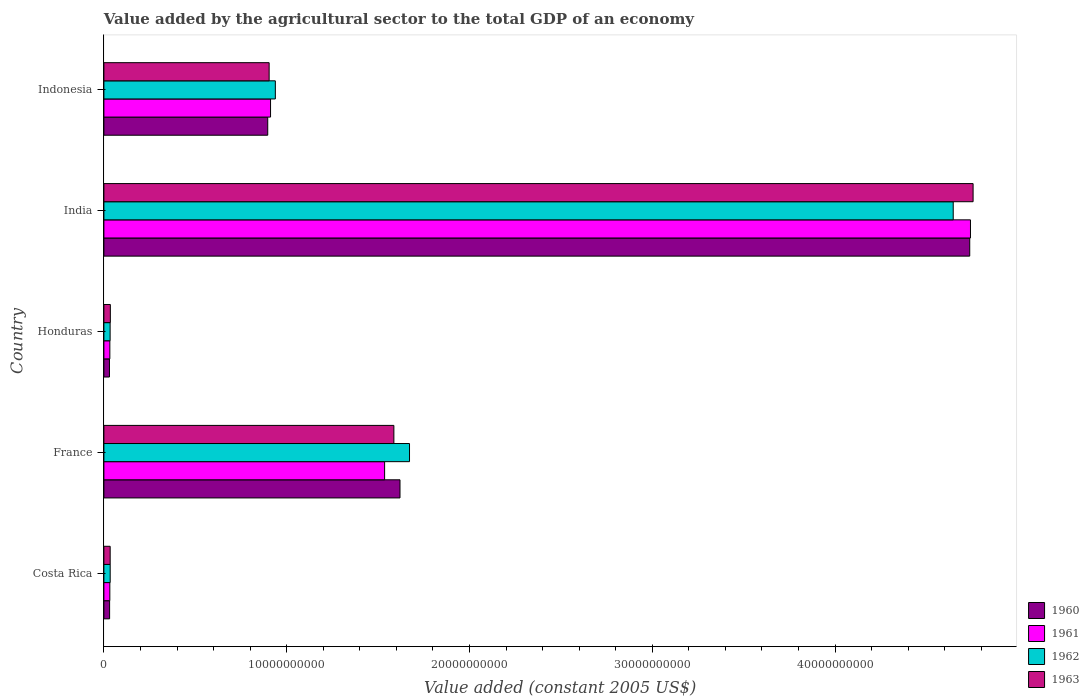Are the number of bars on each tick of the Y-axis equal?
Provide a succinct answer. Yes. How many bars are there on the 3rd tick from the top?
Your answer should be compact. 4. What is the value added by the agricultural sector in 1962 in Costa Rica?
Offer a very short reply. 3.44e+08. Across all countries, what is the maximum value added by the agricultural sector in 1962?
Your response must be concise. 4.65e+1. Across all countries, what is the minimum value added by the agricultural sector in 1960?
Your answer should be very brief. 3.05e+08. In which country was the value added by the agricultural sector in 1962 maximum?
Keep it short and to the point. India. In which country was the value added by the agricultural sector in 1960 minimum?
Make the answer very short. Honduras. What is the total value added by the agricultural sector in 1963 in the graph?
Your response must be concise. 7.32e+1. What is the difference between the value added by the agricultural sector in 1962 in Costa Rica and that in Honduras?
Your response must be concise. 3.61e+06. What is the difference between the value added by the agricultural sector in 1961 in India and the value added by the agricultural sector in 1963 in Honduras?
Keep it short and to the point. 4.71e+1. What is the average value added by the agricultural sector in 1961 per country?
Your answer should be very brief. 1.45e+1. What is the difference between the value added by the agricultural sector in 1962 and value added by the agricultural sector in 1963 in France?
Your answer should be compact. 8.56e+08. In how many countries, is the value added by the agricultural sector in 1961 greater than 40000000000 US$?
Offer a terse response. 1. What is the ratio of the value added by the agricultural sector in 1961 in Costa Rica to that in France?
Provide a short and direct response. 0.02. Is the value added by the agricultural sector in 1963 in France less than that in India?
Provide a succinct answer. Yes. What is the difference between the highest and the second highest value added by the agricultural sector in 1962?
Provide a succinct answer. 2.97e+1. What is the difference between the highest and the lowest value added by the agricultural sector in 1963?
Your answer should be compact. 4.72e+1. In how many countries, is the value added by the agricultural sector in 1960 greater than the average value added by the agricultural sector in 1960 taken over all countries?
Keep it short and to the point. 2. Is the sum of the value added by the agricultural sector in 1963 in India and Indonesia greater than the maximum value added by the agricultural sector in 1961 across all countries?
Provide a succinct answer. Yes. Where does the legend appear in the graph?
Keep it short and to the point. Bottom right. How many legend labels are there?
Make the answer very short. 4. How are the legend labels stacked?
Your answer should be very brief. Vertical. What is the title of the graph?
Offer a very short reply. Value added by the agricultural sector to the total GDP of an economy. Does "1996" appear as one of the legend labels in the graph?
Your answer should be very brief. No. What is the label or title of the X-axis?
Provide a short and direct response. Value added (constant 2005 US$). What is the Value added (constant 2005 US$) in 1960 in Costa Rica?
Offer a very short reply. 3.13e+08. What is the Value added (constant 2005 US$) in 1961 in Costa Rica?
Offer a very short reply. 3.24e+08. What is the Value added (constant 2005 US$) in 1962 in Costa Rica?
Keep it short and to the point. 3.44e+08. What is the Value added (constant 2005 US$) in 1963 in Costa Rica?
Provide a short and direct response. 3.43e+08. What is the Value added (constant 2005 US$) of 1960 in France?
Make the answer very short. 1.62e+1. What is the Value added (constant 2005 US$) of 1961 in France?
Offer a terse response. 1.54e+1. What is the Value added (constant 2005 US$) of 1962 in France?
Your answer should be very brief. 1.67e+1. What is the Value added (constant 2005 US$) in 1963 in France?
Offer a very short reply. 1.59e+1. What is the Value added (constant 2005 US$) of 1960 in Honduras?
Offer a terse response. 3.05e+08. What is the Value added (constant 2005 US$) of 1961 in Honduras?
Ensure brevity in your answer.  3.25e+08. What is the Value added (constant 2005 US$) in 1962 in Honduras?
Ensure brevity in your answer.  3.41e+08. What is the Value added (constant 2005 US$) of 1963 in Honduras?
Ensure brevity in your answer.  3.53e+08. What is the Value added (constant 2005 US$) in 1960 in India?
Provide a succinct answer. 4.74e+1. What is the Value added (constant 2005 US$) of 1961 in India?
Make the answer very short. 4.74e+1. What is the Value added (constant 2005 US$) in 1962 in India?
Offer a terse response. 4.65e+1. What is the Value added (constant 2005 US$) of 1963 in India?
Ensure brevity in your answer.  4.76e+1. What is the Value added (constant 2005 US$) in 1960 in Indonesia?
Provide a short and direct response. 8.96e+09. What is the Value added (constant 2005 US$) of 1961 in Indonesia?
Provide a succinct answer. 9.12e+09. What is the Value added (constant 2005 US$) in 1962 in Indonesia?
Your answer should be compact. 9.38e+09. What is the Value added (constant 2005 US$) in 1963 in Indonesia?
Ensure brevity in your answer.  9.04e+09. Across all countries, what is the maximum Value added (constant 2005 US$) in 1960?
Make the answer very short. 4.74e+1. Across all countries, what is the maximum Value added (constant 2005 US$) of 1961?
Offer a terse response. 4.74e+1. Across all countries, what is the maximum Value added (constant 2005 US$) of 1962?
Ensure brevity in your answer.  4.65e+1. Across all countries, what is the maximum Value added (constant 2005 US$) of 1963?
Your answer should be very brief. 4.76e+1. Across all countries, what is the minimum Value added (constant 2005 US$) in 1960?
Ensure brevity in your answer.  3.05e+08. Across all countries, what is the minimum Value added (constant 2005 US$) in 1961?
Offer a terse response. 3.24e+08. Across all countries, what is the minimum Value added (constant 2005 US$) in 1962?
Your response must be concise. 3.41e+08. Across all countries, what is the minimum Value added (constant 2005 US$) of 1963?
Ensure brevity in your answer.  3.43e+08. What is the total Value added (constant 2005 US$) of 1960 in the graph?
Ensure brevity in your answer.  7.31e+1. What is the total Value added (constant 2005 US$) in 1961 in the graph?
Your response must be concise. 7.25e+1. What is the total Value added (constant 2005 US$) of 1962 in the graph?
Keep it short and to the point. 7.32e+1. What is the total Value added (constant 2005 US$) in 1963 in the graph?
Offer a very short reply. 7.32e+1. What is the difference between the Value added (constant 2005 US$) in 1960 in Costa Rica and that in France?
Give a very brief answer. -1.59e+1. What is the difference between the Value added (constant 2005 US$) of 1961 in Costa Rica and that in France?
Offer a terse response. -1.50e+1. What is the difference between the Value added (constant 2005 US$) in 1962 in Costa Rica and that in France?
Provide a succinct answer. -1.64e+1. What is the difference between the Value added (constant 2005 US$) of 1963 in Costa Rica and that in France?
Give a very brief answer. -1.55e+1. What is the difference between the Value added (constant 2005 US$) in 1960 in Costa Rica and that in Honduras?
Keep it short and to the point. 7.61e+06. What is the difference between the Value added (constant 2005 US$) in 1961 in Costa Rica and that in Honduras?
Make the answer very short. -8.14e+05. What is the difference between the Value added (constant 2005 US$) of 1962 in Costa Rica and that in Honduras?
Provide a short and direct response. 3.61e+06. What is the difference between the Value added (constant 2005 US$) of 1963 in Costa Rica and that in Honduras?
Your answer should be very brief. -9.78e+06. What is the difference between the Value added (constant 2005 US$) of 1960 in Costa Rica and that in India?
Offer a terse response. -4.71e+1. What is the difference between the Value added (constant 2005 US$) of 1961 in Costa Rica and that in India?
Your response must be concise. -4.71e+1. What is the difference between the Value added (constant 2005 US$) of 1962 in Costa Rica and that in India?
Your answer should be compact. -4.61e+1. What is the difference between the Value added (constant 2005 US$) of 1963 in Costa Rica and that in India?
Provide a short and direct response. -4.72e+1. What is the difference between the Value added (constant 2005 US$) of 1960 in Costa Rica and that in Indonesia?
Make the answer very short. -8.65e+09. What is the difference between the Value added (constant 2005 US$) of 1961 in Costa Rica and that in Indonesia?
Keep it short and to the point. -8.79e+09. What is the difference between the Value added (constant 2005 US$) of 1962 in Costa Rica and that in Indonesia?
Offer a very short reply. -9.03e+09. What is the difference between the Value added (constant 2005 US$) of 1963 in Costa Rica and that in Indonesia?
Make the answer very short. -8.70e+09. What is the difference between the Value added (constant 2005 US$) in 1960 in France and that in Honduras?
Make the answer very short. 1.59e+1. What is the difference between the Value added (constant 2005 US$) of 1961 in France and that in Honduras?
Provide a short and direct response. 1.50e+1. What is the difference between the Value added (constant 2005 US$) of 1962 in France and that in Honduras?
Provide a succinct answer. 1.64e+1. What is the difference between the Value added (constant 2005 US$) in 1963 in France and that in Honduras?
Make the answer very short. 1.55e+1. What is the difference between the Value added (constant 2005 US$) of 1960 in France and that in India?
Your answer should be compact. -3.12e+1. What is the difference between the Value added (constant 2005 US$) in 1961 in France and that in India?
Make the answer very short. -3.21e+1. What is the difference between the Value added (constant 2005 US$) of 1962 in France and that in India?
Your response must be concise. -2.97e+1. What is the difference between the Value added (constant 2005 US$) of 1963 in France and that in India?
Your answer should be compact. -3.17e+1. What is the difference between the Value added (constant 2005 US$) in 1960 in France and that in Indonesia?
Your response must be concise. 7.24e+09. What is the difference between the Value added (constant 2005 US$) of 1961 in France and that in Indonesia?
Your answer should be very brief. 6.24e+09. What is the difference between the Value added (constant 2005 US$) of 1962 in France and that in Indonesia?
Provide a short and direct response. 7.34e+09. What is the difference between the Value added (constant 2005 US$) of 1963 in France and that in Indonesia?
Give a very brief answer. 6.82e+09. What is the difference between the Value added (constant 2005 US$) in 1960 in Honduras and that in India?
Give a very brief answer. -4.71e+1. What is the difference between the Value added (constant 2005 US$) of 1961 in Honduras and that in India?
Offer a terse response. -4.71e+1. What is the difference between the Value added (constant 2005 US$) in 1962 in Honduras and that in India?
Provide a succinct answer. -4.61e+1. What is the difference between the Value added (constant 2005 US$) in 1963 in Honduras and that in India?
Your answer should be compact. -4.72e+1. What is the difference between the Value added (constant 2005 US$) in 1960 in Honduras and that in Indonesia?
Your answer should be very brief. -8.66e+09. What is the difference between the Value added (constant 2005 US$) in 1961 in Honduras and that in Indonesia?
Your answer should be compact. -8.79e+09. What is the difference between the Value added (constant 2005 US$) of 1962 in Honduras and that in Indonesia?
Offer a very short reply. -9.04e+09. What is the difference between the Value added (constant 2005 US$) in 1963 in Honduras and that in Indonesia?
Your answer should be very brief. -8.69e+09. What is the difference between the Value added (constant 2005 US$) of 1960 in India and that in Indonesia?
Your answer should be compact. 3.84e+1. What is the difference between the Value added (constant 2005 US$) of 1961 in India and that in Indonesia?
Keep it short and to the point. 3.83e+1. What is the difference between the Value added (constant 2005 US$) of 1962 in India and that in Indonesia?
Make the answer very short. 3.71e+1. What is the difference between the Value added (constant 2005 US$) of 1963 in India and that in Indonesia?
Keep it short and to the point. 3.85e+1. What is the difference between the Value added (constant 2005 US$) in 1960 in Costa Rica and the Value added (constant 2005 US$) in 1961 in France?
Give a very brief answer. -1.50e+1. What is the difference between the Value added (constant 2005 US$) of 1960 in Costa Rica and the Value added (constant 2005 US$) of 1962 in France?
Give a very brief answer. -1.64e+1. What is the difference between the Value added (constant 2005 US$) in 1960 in Costa Rica and the Value added (constant 2005 US$) in 1963 in France?
Provide a succinct answer. -1.56e+1. What is the difference between the Value added (constant 2005 US$) in 1961 in Costa Rica and the Value added (constant 2005 US$) in 1962 in France?
Offer a terse response. -1.64e+1. What is the difference between the Value added (constant 2005 US$) of 1961 in Costa Rica and the Value added (constant 2005 US$) of 1963 in France?
Keep it short and to the point. -1.55e+1. What is the difference between the Value added (constant 2005 US$) in 1962 in Costa Rica and the Value added (constant 2005 US$) in 1963 in France?
Make the answer very short. -1.55e+1. What is the difference between the Value added (constant 2005 US$) of 1960 in Costa Rica and the Value added (constant 2005 US$) of 1961 in Honduras?
Give a very brief answer. -1.23e+07. What is the difference between the Value added (constant 2005 US$) of 1960 in Costa Rica and the Value added (constant 2005 US$) of 1962 in Honduras?
Your response must be concise. -2.78e+07. What is the difference between the Value added (constant 2005 US$) in 1960 in Costa Rica and the Value added (constant 2005 US$) in 1963 in Honduras?
Make the answer very short. -4.02e+07. What is the difference between the Value added (constant 2005 US$) in 1961 in Costa Rica and the Value added (constant 2005 US$) in 1962 in Honduras?
Give a very brief answer. -1.63e+07. What is the difference between the Value added (constant 2005 US$) in 1961 in Costa Rica and the Value added (constant 2005 US$) in 1963 in Honduras?
Keep it short and to the point. -2.87e+07. What is the difference between the Value added (constant 2005 US$) of 1962 in Costa Rica and the Value added (constant 2005 US$) of 1963 in Honduras?
Provide a succinct answer. -8.78e+06. What is the difference between the Value added (constant 2005 US$) of 1960 in Costa Rica and the Value added (constant 2005 US$) of 1961 in India?
Your answer should be very brief. -4.71e+1. What is the difference between the Value added (constant 2005 US$) of 1960 in Costa Rica and the Value added (constant 2005 US$) of 1962 in India?
Your answer should be very brief. -4.62e+1. What is the difference between the Value added (constant 2005 US$) in 1960 in Costa Rica and the Value added (constant 2005 US$) in 1963 in India?
Your answer should be very brief. -4.72e+1. What is the difference between the Value added (constant 2005 US$) in 1961 in Costa Rica and the Value added (constant 2005 US$) in 1962 in India?
Offer a very short reply. -4.61e+1. What is the difference between the Value added (constant 2005 US$) of 1961 in Costa Rica and the Value added (constant 2005 US$) of 1963 in India?
Your response must be concise. -4.72e+1. What is the difference between the Value added (constant 2005 US$) in 1962 in Costa Rica and the Value added (constant 2005 US$) in 1963 in India?
Provide a succinct answer. -4.72e+1. What is the difference between the Value added (constant 2005 US$) of 1960 in Costa Rica and the Value added (constant 2005 US$) of 1961 in Indonesia?
Ensure brevity in your answer.  -8.80e+09. What is the difference between the Value added (constant 2005 US$) of 1960 in Costa Rica and the Value added (constant 2005 US$) of 1962 in Indonesia?
Your answer should be compact. -9.07e+09. What is the difference between the Value added (constant 2005 US$) of 1960 in Costa Rica and the Value added (constant 2005 US$) of 1963 in Indonesia?
Give a very brief answer. -8.73e+09. What is the difference between the Value added (constant 2005 US$) of 1961 in Costa Rica and the Value added (constant 2005 US$) of 1962 in Indonesia?
Your answer should be compact. -9.05e+09. What is the difference between the Value added (constant 2005 US$) of 1961 in Costa Rica and the Value added (constant 2005 US$) of 1963 in Indonesia?
Offer a very short reply. -8.72e+09. What is the difference between the Value added (constant 2005 US$) of 1962 in Costa Rica and the Value added (constant 2005 US$) of 1963 in Indonesia?
Offer a terse response. -8.70e+09. What is the difference between the Value added (constant 2005 US$) of 1960 in France and the Value added (constant 2005 US$) of 1961 in Honduras?
Provide a short and direct response. 1.59e+1. What is the difference between the Value added (constant 2005 US$) of 1960 in France and the Value added (constant 2005 US$) of 1962 in Honduras?
Make the answer very short. 1.59e+1. What is the difference between the Value added (constant 2005 US$) in 1960 in France and the Value added (constant 2005 US$) in 1963 in Honduras?
Give a very brief answer. 1.58e+1. What is the difference between the Value added (constant 2005 US$) of 1961 in France and the Value added (constant 2005 US$) of 1962 in Honduras?
Ensure brevity in your answer.  1.50e+1. What is the difference between the Value added (constant 2005 US$) in 1961 in France and the Value added (constant 2005 US$) in 1963 in Honduras?
Offer a terse response. 1.50e+1. What is the difference between the Value added (constant 2005 US$) in 1962 in France and the Value added (constant 2005 US$) in 1963 in Honduras?
Your response must be concise. 1.64e+1. What is the difference between the Value added (constant 2005 US$) of 1960 in France and the Value added (constant 2005 US$) of 1961 in India?
Keep it short and to the point. -3.12e+1. What is the difference between the Value added (constant 2005 US$) in 1960 in France and the Value added (constant 2005 US$) in 1962 in India?
Make the answer very short. -3.03e+1. What is the difference between the Value added (constant 2005 US$) of 1960 in France and the Value added (constant 2005 US$) of 1963 in India?
Offer a very short reply. -3.14e+1. What is the difference between the Value added (constant 2005 US$) in 1961 in France and the Value added (constant 2005 US$) in 1962 in India?
Offer a terse response. -3.11e+1. What is the difference between the Value added (constant 2005 US$) in 1961 in France and the Value added (constant 2005 US$) in 1963 in India?
Offer a terse response. -3.22e+1. What is the difference between the Value added (constant 2005 US$) in 1962 in France and the Value added (constant 2005 US$) in 1963 in India?
Provide a succinct answer. -3.08e+1. What is the difference between the Value added (constant 2005 US$) in 1960 in France and the Value added (constant 2005 US$) in 1961 in Indonesia?
Provide a succinct answer. 7.08e+09. What is the difference between the Value added (constant 2005 US$) of 1960 in France and the Value added (constant 2005 US$) of 1962 in Indonesia?
Your response must be concise. 6.82e+09. What is the difference between the Value added (constant 2005 US$) of 1960 in France and the Value added (constant 2005 US$) of 1963 in Indonesia?
Provide a short and direct response. 7.16e+09. What is the difference between the Value added (constant 2005 US$) in 1961 in France and the Value added (constant 2005 US$) in 1962 in Indonesia?
Provide a short and direct response. 5.98e+09. What is the difference between the Value added (constant 2005 US$) in 1961 in France and the Value added (constant 2005 US$) in 1963 in Indonesia?
Provide a short and direct response. 6.32e+09. What is the difference between the Value added (constant 2005 US$) in 1962 in France and the Value added (constant 2005 US$) in 1963 in Indonesia?
Make the answer very short. 7.68e+09. What is the difference between the Value added (constant 2005 US$) in 1960 in Honduras and the Value added (constant 2005 US$) in 1961 in India?
Your answer should be compact. -4.71e+1. What is the difference between the Value added (constant 2005 US$) of 1960 in Honduras and the Value added (constant 2005 US$) of 1962 in India?
Ensure brevity in your answer.  -4.62e+1. What is the difference between the Value added (constant 2005 US$) of 1960 in Honduras and the Value added (constant 2005 US$) of 1963 in India?
Offer a terse response. -4.72e+1. What is the difference between the Value added (constant 2005 US$) in 1961 in Honduras and the Value added (constant 2005 US$) in 1962 in India?
Ensure brevity in your answer.  -4.61e+1. What is the difference between the Value added (constant 2005 US$) in 1961 in Honduras and the Value added (constant 2005 US$) in 1963 in India?
Offer a terse response. -4.72e+1. What is the difference between the Value added (constant 2005 US$) of 1962 in Honduras and the Value added (constant 2005 US$) of 1963 in India?
Offer a terse response. -4.72e+1. What is the difference between the Value added (constant 2005 US$) in 1960 in Honduras and the Value added (constant 2005 US$) in 1961 in Indonesia?
Your response must be concise. -8.81e+09. What is the difference between the Value added (constant 2005 US$) in 1960 in Honduras and the Value added (constant 2005 US$) in 1962 in Indonesia?
Ensure brevity in your answer.  -9.07e+09. What is the difference between the Value added (constant 2005 US$) of 1960 in Honduras and the Value added (constant 2005 US$) of 1963 in Indonesia?
Provide a short and direct response. -8.73e+09. What is the difference between the Value added (constant 2005 US$) of 1961 in Honduras and the Value added (constant 2005 US$) of 1962 in Indonesia?
Make the answer very short. -9.05e+09. What is the difference between the Value added (constant 2005 US$) in 1961 in Honduras and the Value added (constant 2005 US$) in 1963 in Indonesia?
Give a very brief answer. -8.72e+09. What is the difference between the Value added (constant 2005 US$) of 1962 in Honduras and the Value added (constant 2005 US$) of 1963 in Indonesia?
Provide a succinct answer. -8.70e+09. What is the difference between the Value added (constant 2005 US$) in 1960 in India and the Value added (constant 2005 US$) in 1961 in Indonesia?
Provide a short and direct response. 3.83e+1. What is the difference between the Value added (constant 2005 US$) of 1960 in India and the Value added (constant 2005 US$) of 1962 in Indonesia?
Your answer should be compact. 3.80e+1. What is the difference between the Value added (constant 2005 US$) of 1960 in India and the Value added (constant 2005 US$) of 1963 in Indonesia?
Your answer should be compact. 3.83e+1. What is the difference between the Value added (constant 2005 US$) of 1961 in India and the Value added (constant 2005 US$) of 1962 in Indonesia?
Make the answer very short. 3.80e+1. What is the difference between the Value added (constant 2005 US$) of 1961 in India and the Value added (constant 2005 US$) of 1963 in Indonesia?
Give a very brief answer. 3.84e+1. What is the difference between the Value added (constant 2005 US$) of 1962 in India and the Value added (constant 2005 US$) of 1963 in Indonesia?
Provide a succinct answer. 3.74e+1. What is the average Value added (constant 2005 US$) of 1960 per country?
Provide a short and direct response. 1.46e+1. What is the average Value added (constant 2005 US$) of 1961 per country?
Your answer should be very brief. 1.45e+1. What is the average Value added (constant 2005 US$) in 1962 per country?
Make the answer very short. 1.46e+1. What is the average Value added (constant 2005 US$) in 1963 per country?
Ensure brevity in your answer.  1.46e+1. What is the difference between the Value added (constant 2005 US$) in 1960 and Value added (constant 2005 US$) in 1961 in Costa Rica?
Your answer should be compact. -1.15e+07. What is the difference between the Value added (constant 2005 US$) of 1960 and Value added (constant 2005 US$) of 1962 in Costa Rica?
Make the answer very short. -3.14e+07. What is the difference between the Value added (constant 2005 US$) of 1960 and Value added (constant 2005 US$) of 1963 in Costa Rica?
Your answer should be compact. -3.04e+07. What is the difference between the Value added (constant 2005 US$) of 1961 and Value added (constant 2005 US$) of 1962 in Costa Rica?
Offer a terse response. -1.99e+07. What is the difference between the Value added (constant 2005 US$) in 1961 and Value added (constant 2005 US$) in 1963 in Costa Rica?
Offer a very short reply. -1.89e+07. What is the difference between the Value added (constant 2005 US$) of 1962 and Value added (constant 2005 US$) of 1963 in Costa Rica?
Provide a short and direct response. 1.00e+06. What is the difference between the Value added (constant 2005 US$) of 1960 and Value added (constant 2005 US$) of 1961 in France?
Offer a very short reply. 8.42e+08. What is the difference between the Value added (constant 2005 US$) in 1960 and Value added (constant 2005 US$) in 1962 in France?
Make the answer very short. -5.20e+08. What is the difference between the Value added (constant 2005 US$) in 1960 and Value added (constant 2005 US$) in 1963 in France?
Your answer should be very brief. 3.35e+08. What is the difference between the Value added (constant 2005 US$) in 1961 and Value added (constant 2005 US$) in 1962 in France?
Offer a terse response. -1.36e+09. What is the difference between the Value added (constant 2005 US$) in 1961 and Value added (constant 2005 US$) in 1963 in France?
Make the answer very short. -5.07e+08. What is the difference between the Value added (constant 2005 US$) of 1962 and Value added (constant 2005 US$) of 1963 in France?
Offer a terse response. 8.56e+08. What is the difference between the Value added (constant 2005 US$) of 1960 and Value added (constant 2005 US$) of 1961 in Honduras?
Provide a succinct answer. -1.99e+07. What is the difference between the Value added (constant 2005 US$) of 1960 and Value added (constant 2005 US$) of 1962 in Honduras?
Your answer should be compact. -3.54e+07. What is the difference between the Value added (constant 2005 US$) of 1960 and Value added (constant 2005 US$) of 1963 in Honduras?
Ensure brevity in your answer.  -4.78e+07. What is the difference between the Value added (constant 2005 US$) in 1961 and Value added (constant 2005 US$) in 1962 in Honduras?
Ensure brevity in your answer.  -1.55e+07. What is the difference between the Value added (constant 2005 US$) of 1961 and Value added (constant 2005 US$) of 1963 in Honduras?
Offer a very short reply. -2.79e+07. What is the difference between the Value added (constant 2005 US$) in 1962 and Value added (constant 2005 US$) in 1963 in Honduras?
Your answer should be very brief. -1.24e+07. What is the difference between the Value added (constant 2005 US$) of 1960 and Value added (constant 2005 US$) of 1961 in India?
Give a very brief answer. -3.99e+07. What is the difference between the Value added (constant 2005 US$) of 1960 and Value added (constant 2005 US$) of 1962 in India?
Offer a very short reply. 9.03e+08. What is the difference between the Value added (constant 2005 US$) in 1960 and Value added (constant 2005 US$) in 1963 in India?
Provide a short and direct response. -1.84e+08. What is the difference between the Value added (constant 2005 US$) in 1961 and Value added (constant 2005 US$) in 1962 in India?
Ensure brevity in your answer.  9.43e+08. What is the difference between the Value added (constant 2005 US$) of 1961 and Value added (constant 2005 US$) of 1963 in India?
Your answer should be compact. -1.44e+08. What is the difference between the Value added (constant 2005 US$) in 1962 and Value added (constant 2005 US$) in 1963 in India?
Make the answer very short. -1.09e+09. What is the difference between the Value added (constant 2005 US$) in 1960 and Value added (constant 2005 US$) in 1961 in Indonesia?
Make the answer very short. -1.54e+08. What is the difference between the Value added (constant 2005 US$) of 1960 and Value added (constant 2005 US$) of 1962 in Indonesia?
Offer a very short reply. -4.16e+08. What is the difference between the Value added (constant 2005 US$) in 1960 and Value added (constant 2005 US$) in 1963 in Indonesia?
Ensure brevity in your answer.  -7.71e+07. What is the difference between the Value added (constant 2005 US$) of 1961 and Value added (constant 2005 US$) of 1962 in Indonesia?
Your answer should be very brief. -2.62e+08. What is the difference between the Value added (constant 2005 US$) of 1961 and Value added (constant 2005 US$) of 1963 in Indonesia?
Provide a short and direct response. 7.71e+07. What is the difference between the Value added (constant 2005 US$) in 1962 and Value added (constant 2005 US$) in 1963 in Indonesia?
Offer a terse response. 3.39e+08. What is the ratio of the Value added (constant 2005 US$) of 1960 in Costa Rica to that in France?
Your answer should be compact. 0.02. What is the ratio of the Value added (constant 2005 US$) in 1961 in Costa Rica to that in France?
Keep it short and to the point. 0.02. What is the ratio of the Value added (constant 2005 US$) in 1962 in Costa Rica to that in France?
Your answer should be compact. 0.02. What is the ratio of the Value added (constant 2005 US$) of 1963 in Costa Rica to that in France?
Your response must be concise. 0.02. What is the ratio of the Value added (constant 2005 US$) in 1960 in Costa Rica to that in Honduras?
Offer a terse response. 1.02. What is the ratio of the Value added (constant 2005 US$) of 1962 in Costa Rica to that in Honduras?
Give a very brief answer. 1.01. What is the ratio of the Value added (constant 2005 US$) in 1963 in Costa Rica to that in Honduras?
Provide a succinct answer. 0.97. What is the ratio of the Value added (constant 2005 US$) of 1960 in Costa Rica to that in India?
Your answer should be very brief. 0.01. What is the ratio of the Value added (constant 2005 US$) of 1961 in Costa Rica to that in India?
Your answer should be compact. 0.01. What is the ratio of the Value added (constant 2005 US$) in 1962 in Costa Rica to that in India?
Offer a very short reply. 0.01. What is the ratio of the Value added (constant 2005 US$) in 1963 in Costa Rica to that in India?
Ensure brevity in your answer.  0.01. What is the ratio of the Value added (constant 2005 US$) of 1960 in Costa Rica to that in Indonesia?
Keep it short and to the point. 0.03. What is the ratio of the Value added (constant 2005 US$) of 1961 in Costa Rica to that in Indonesia?
Make the answer very short. 0.04. What is the ratio of the Value added (constant 2005 US$) of 1962 in Costa Rica to that in Indonesia?
Your answer should be compact. 0.04. What is the ratio of the Value added (constant 2005 US$) in 1963 in Costa Rica to that in Indonesia?
Your response must be concise. 0.04. What is the ratio of the Value added (constant 2005 US$) of 1960 in France to that in Honduras?
Provide a succinct answer. 53.05. What is the ratio of the Value added (constant 2005 US$) in 1961 in France to that in Honduras?
Offer a terse response. 47.21. What is the ratio of the Value added (constant 2005 US$) of 1962 in France to that in Honduras?
Give a very brief answer. 49.07. What is the ratio of the Value added (constant 2005 US$) in 1963 in France to that in Honduras?
Provide a succinct answer. 44.92. What is the ratio of the Value added (constant 2005 US$) in 1960 in France to that in India?
Your answer should be compact. 0.34. What is the ratio of the Value added (constant 2005 US$) of 1961 in France to that in India?
Make the answer very short. 0.32. What is the ratio of the Value added (constant 2005 US$) in 1962 in France to that in India?
Give a very brief answer. 0.36. What is the ratio of the Value added (constant 2005 US$) in 1963 in France to that in India?
Offer a very short reply. 0.33. What is the ratio of the Value added (constant 2005 US$) in 1960 in France to that in Indonesia?
Offer a terse response. 1.81. What is the ratio of the Value added (constant 2005 US$) in 1961 in France to that in Indonesia?
Ensure brevity in your answer.  1.68. What is the ratio of the Value added (constant 2005 US$) in 1962 in France to that in Indonesia?
Your answer should be compact. 1.78. What is the ratio of the Value added (constant 2005 US$) in 1963 in France to that in Indonesia?
Give a very brief answer. 1.75. What is the ratio of the Value added (constant 2005 US$) of 1960 in Honduras to that in India?
Offer a very short reply. 0.01. What is the ratio of the Value added (constant 2005 US$) in 1961 in Honduras to that in India?
Provide a succinct answer. 0.01. What is the ratio of the Value added (constant 2005 US$) in 1962 in Honduras to that in India?
Offer a very short reply. 0.01. What is the ratio of the Value added (constant 2005 US$) in 1963 in Honduras to that in India?
Your answer should be compact. 0.01. What is the ratio of the Value added (constant 2005 US$) of 1960 in Honduras to that in Indonesia?
Ensure brevity in your answer.  0.03. What is the ratio of the Value added (constant 2005 US$) in 1961 in Honduras to that in Indonesia?
Ensure brevity in your answer.  0.04. What is the ratio of the Value added (constant 2005 US$) in 1962 in Honduras to that in Indonesia?
Make the answer very short. 0.04. What is the ratio of the Value added (constant 2005 US$) of 1963 in Honduras to that in Indonesia?
Keep it short and to the point. 0.04. What is the ratio of the Value added (constant 2005 US$) of 1960 in India to that in Indonesia?
Ensure brevity in your answer.  5.28. What is the ratio of the Value added (constant 2005 US$) in 1961 in India to that in Indonesia?
Your answer should be very brief. 5.2. What is the ratio of the Value added (constant 2005 US$) of 1962 in India to that in Indonesia?
Your answer should be very brief. 4.95. What is the ratio of the Value added (constant 2005 US$) in 1963 in India to that in Indonesia?
Keep it short and to the point. 5.26. What is the difference between the highest and the second highest Value added (constant 2005 US$) in 1960?
Your answer should be very brief. 3.12e+1. What is the difference between the highest and the second highest Value added (constant 2005 US$) in 1961?
Your answer should be very brief. 3.21e+1. What is the difference between the highest and the second highest Value added (constant 2005 US$) of 1962?
Provide a short and direct response. 2.97e+1. What is the difference between the highest and the second highest Value added (constant 2005 US$) in 1963?
Offer a very short reply. 3.17e+1. What is the difference between the highest and the lowest Value added (constant 2005 US$) of 1960?
Give a very brief answer. 4.71e+1. What is the difference between the highest and the lowest Value added (constant 2005 US$) in 1961?
Make the answer very short. 4.71e+1. What is the difference between the highest and the lowest Value added (constant 2005 US$) in 1962?
Offer a terse response. 4.61e+1. What is the difference between the highest and the lowest Value added (constant 2005 US$) in 1963?
Provide a short and direct response. 4.72e+1. 